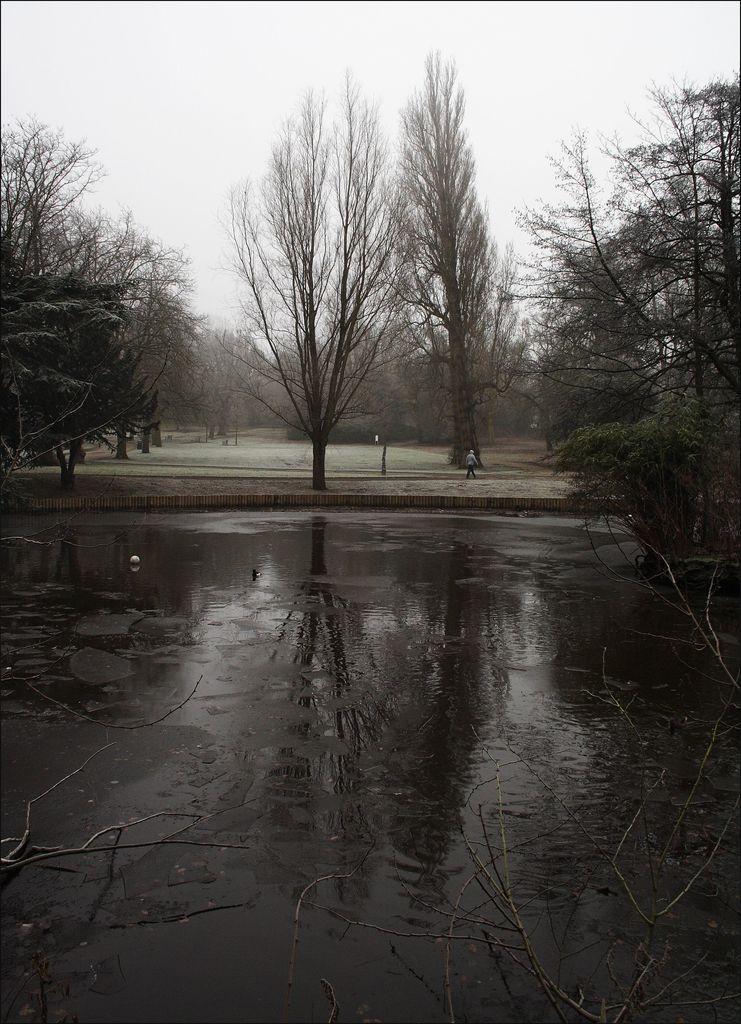In one or two sentences, can you explain what this image depicts? In this image we can see sky, trees, person and water. 